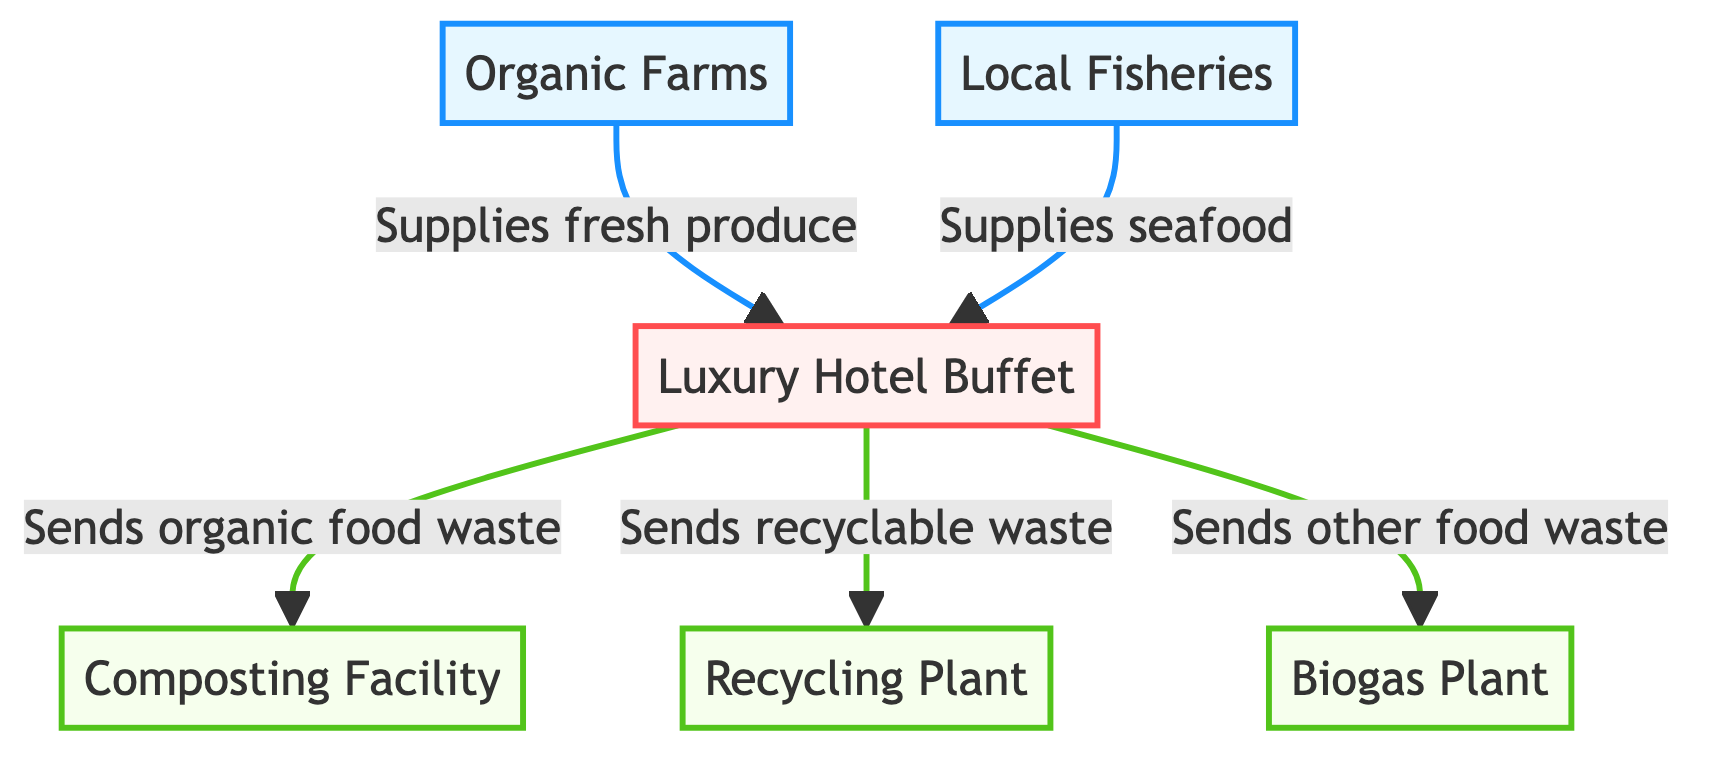What sources supply food to the luxury hotel buffet? The diagram shows two sources that supply food to the luxury hotel buffet: "Organic Farms" and "Local Fisheries." These nodes are directly connected by arrows to the "Luxury Hotel Buffet" node, indicating the flow of fresh produce and seafood to the buffet.
Answer: Organic Farms, Local Fisheries How many waste management facilities are connected to the luxury hotel buffet? The diagram indicates three waste management facilities connected to the luxury hotel buffet: "Composting Facility," "Recycling Plant," and "Biogas Plant." Each is reached by separate outgoing connections from the buffet node, making the total count three.
Answer: 3 What type of waste does the luxury hotel buffet send to the composting facility? The diagram specifies that the luxury hotel buffet sends "organic food waste" to the composting facility. This is indicated by the arrow leading from the buffet to the composting facility labeled with this exact description.
Answer: Organic food waste Which facility receives recyclable waste from the luxury hotel buffet? According to the diagram, the luxury hotel buffet sends "recyclable waste" to the "Recycling Plant." This is illustrated by a direct arrow pointing to the Recycling Plant node, denoting a clear flow of this type of waste.
Answer: Recycling Plant What is the relationship between organic farms and the luxury hotel buffet? The connection between organic farms and the luxury hotel buffet is that organic farms supply fresh produce to the buffet. This relationship is clearly depicted by the directed arrow from "Organic Farms" to "Luxury Hotel Buffet," labeled with the phrase "Supplies fresh produce."
Answer: Supplies fresh produce Which type of waste is sent to the biogas plant? The diagram indicates that the luxury hotel buffet sends "other food waste" to the biogas plant. This is shown with an arrow labeled "Sends other food waste" pointing from the buffet node to the biogas plant node.
Answer: Other food waste How many total nodes are present in the diagram? Counting all the nodes in the diagram, we have three sources (organic farms and local fisheries), one process (luxury hotel buffet), and three waste management facilities (composting facility, recycling plant, biogas plant). This totals to seven distinct nodes in the entire diagram.
Answer: 7 What role do local fisheries play in the luxury hotel buffet's ecosystem? The local fisheries supply seafood to the luxury hotel buffet, as depicted by the arrow from "Local Fisheries" to "Luxury Hotel Buffet," indicating the direct contribution of seafood to the buffet's offerings.
Answer: Supplies seafood 